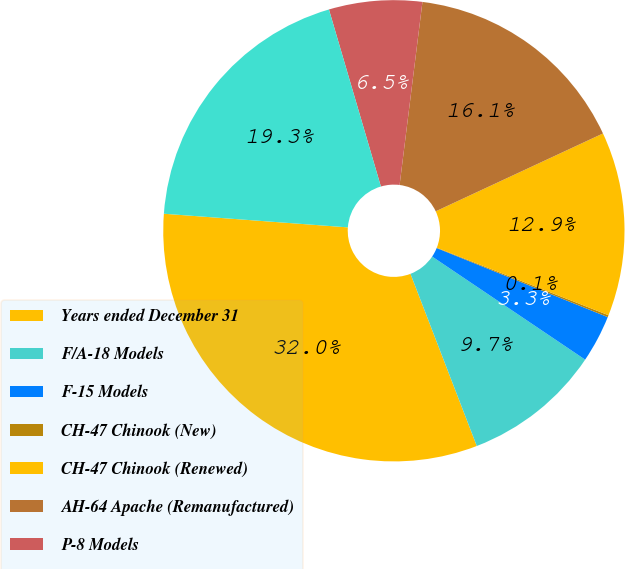Convert chart to OTSL. <chart><loc_0><loc_0><loc_500><loc_500><pie_chart><fcel>Years ended December 31<fcel>F/A-18 Models<fcel>F-15 Models<fcel>CH-47 Chinook (New)<fcel>CH-47 Chinook (Renewed)<fcel>AH-64 Apache (Remanufactured)<fcel>P-8 Models<fcel>Total<nl><fcel>32.03%<fcel>9.71%<fcel>3.33%<fcel>0.14%<fcel>12.9%<fcel>16.09%<fcel>6.52%<fcel>19.28%<nl></chart> 